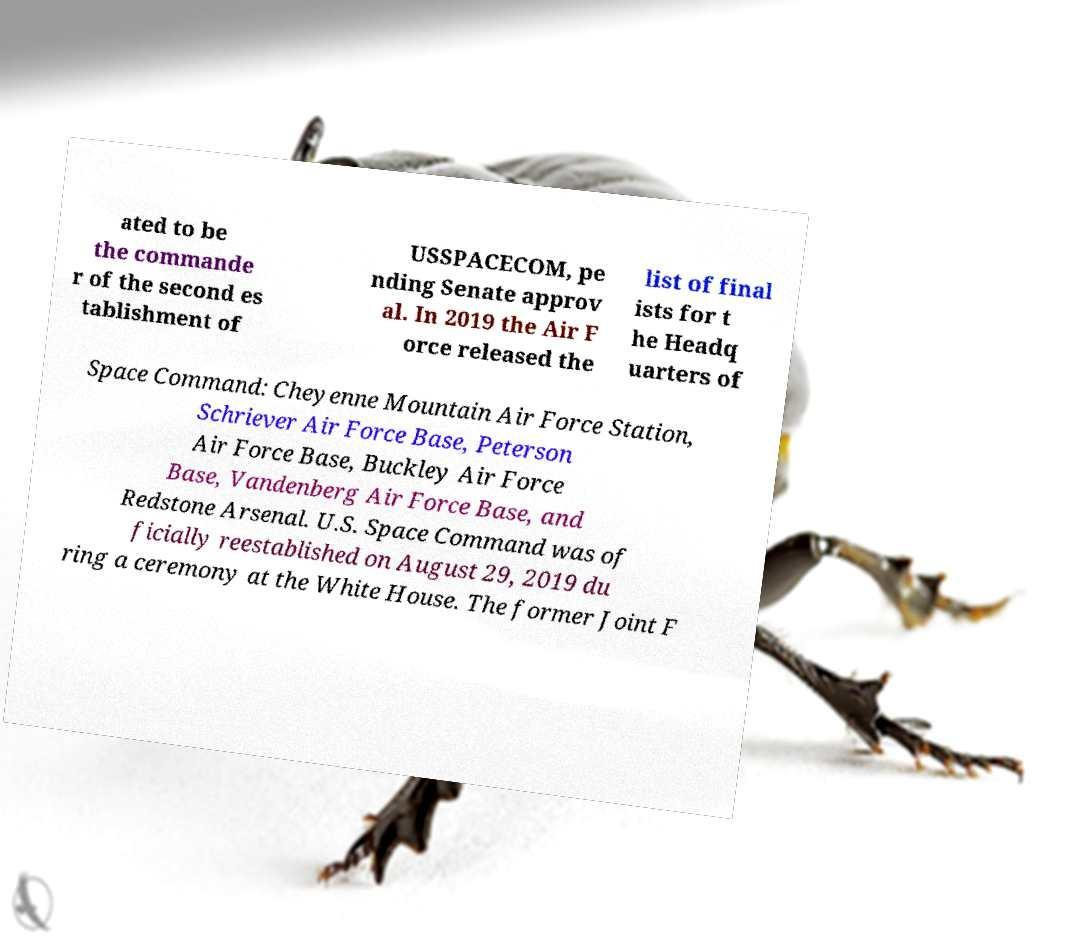For documentation purposes, I need the text within this image transcribed. Could you provide that? ated to be the commande r of the second es tablishment of USSPACECOM, pe nding Senate approv al. In 2019 the Air F orce released the list of final ists for t he Headq uarters of Space Command: Cheyenne Mountain Air Force Station, Schriever Air Force Base, Peterson Air Force Base, Buckley Air Force Base, Vandenberg Air Force Base, and Redstone Arsenal. U.S. Space Command was of ficially reestablished on August 29, 2019 du ring a ceremony at the White House. The former Joint F 